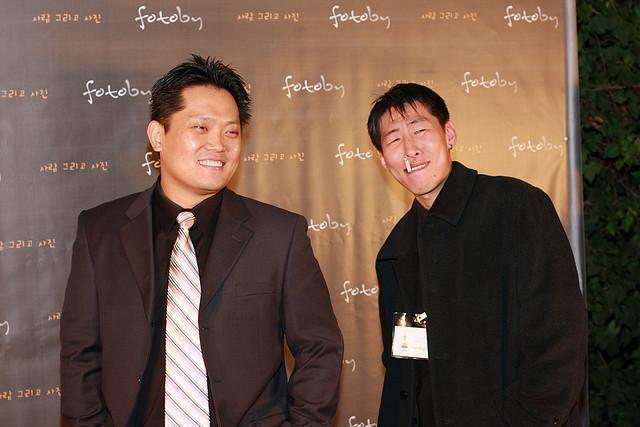Where do these people stand?
Pick the right solution, then justify: 'Answer: answer
Rationale: rationale.'
Options: Photo backdrop, classroom, bathroom, jail. Answer: photo backdrop.
Rationale: The people are standing in front of a tarp that has logos on it. 